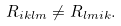Convert formula to latex. <formula><loc_0><loc_0><loc_500><loc_500>R _ { i k l m } \not = R _ { l m i k } .</formula> 